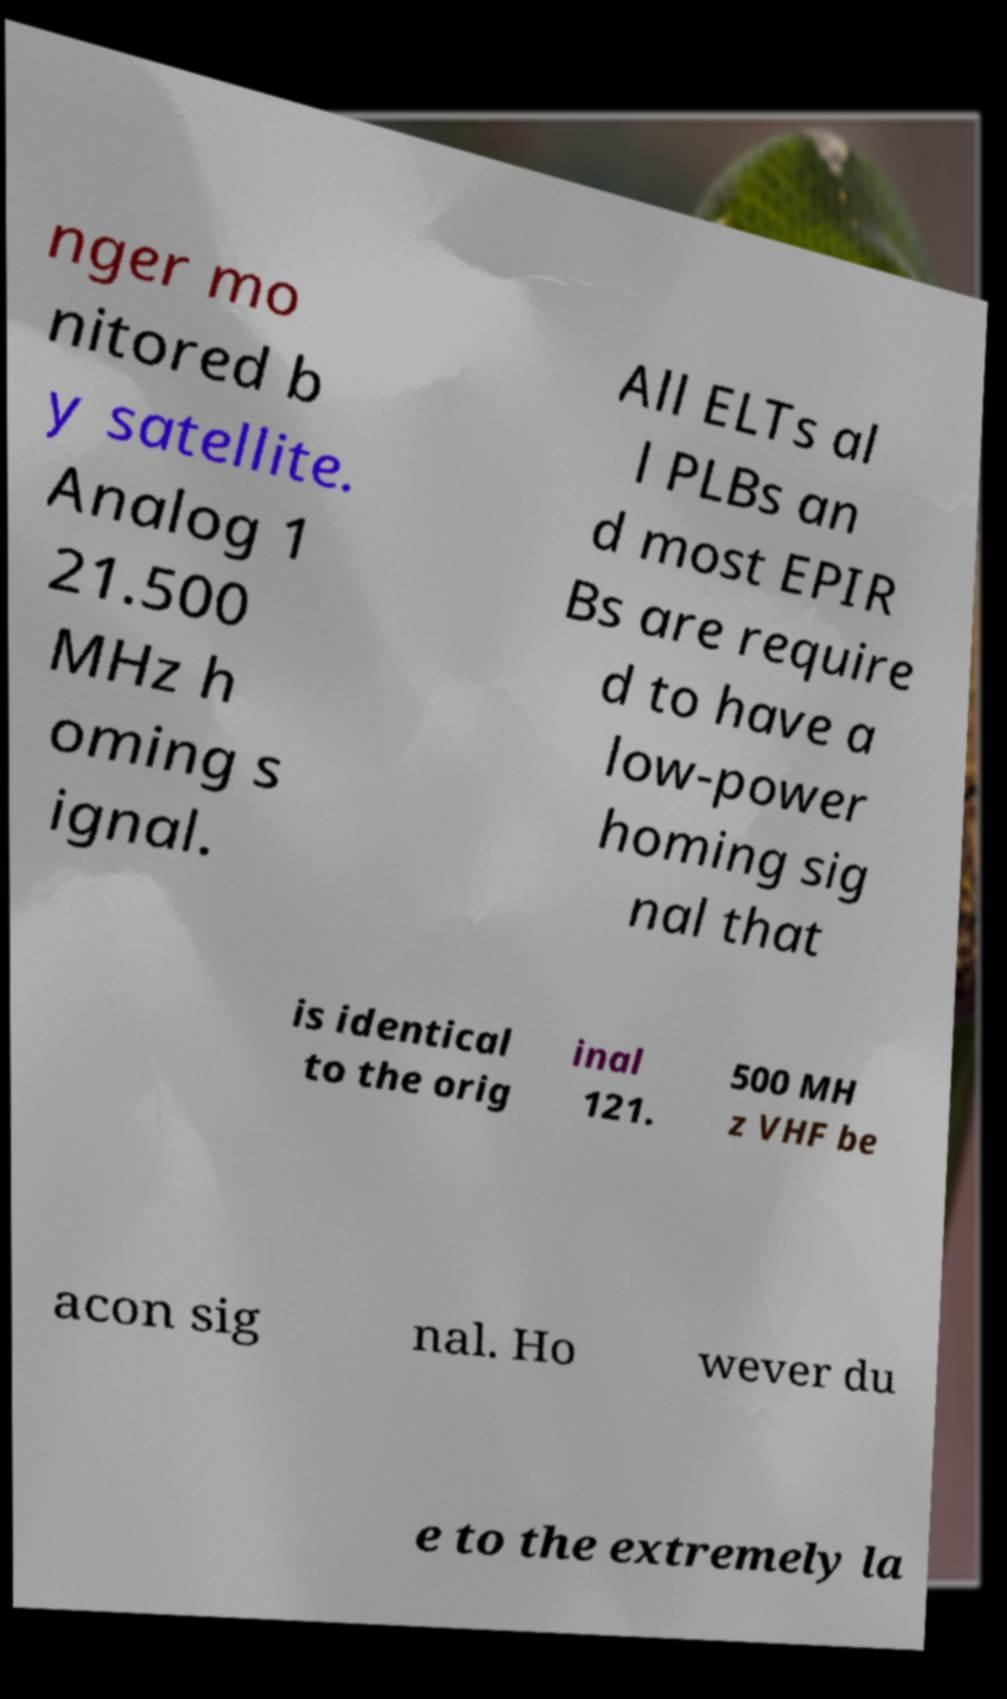Can you read and provide the text displayed in the image?This photo seems to have some interesting text. Can you extract and type it out for me? nger mo nitored b y satellite. Analog 1 21.500 MHz h oming s ignal. All ELTs al l PLBs an d most EPIR Bs are require d to have a low-power homing sig nal that is identical to the orig inal 121. 500 MH z VHF be acon sig nal. Ho wever du e to the extremely la 